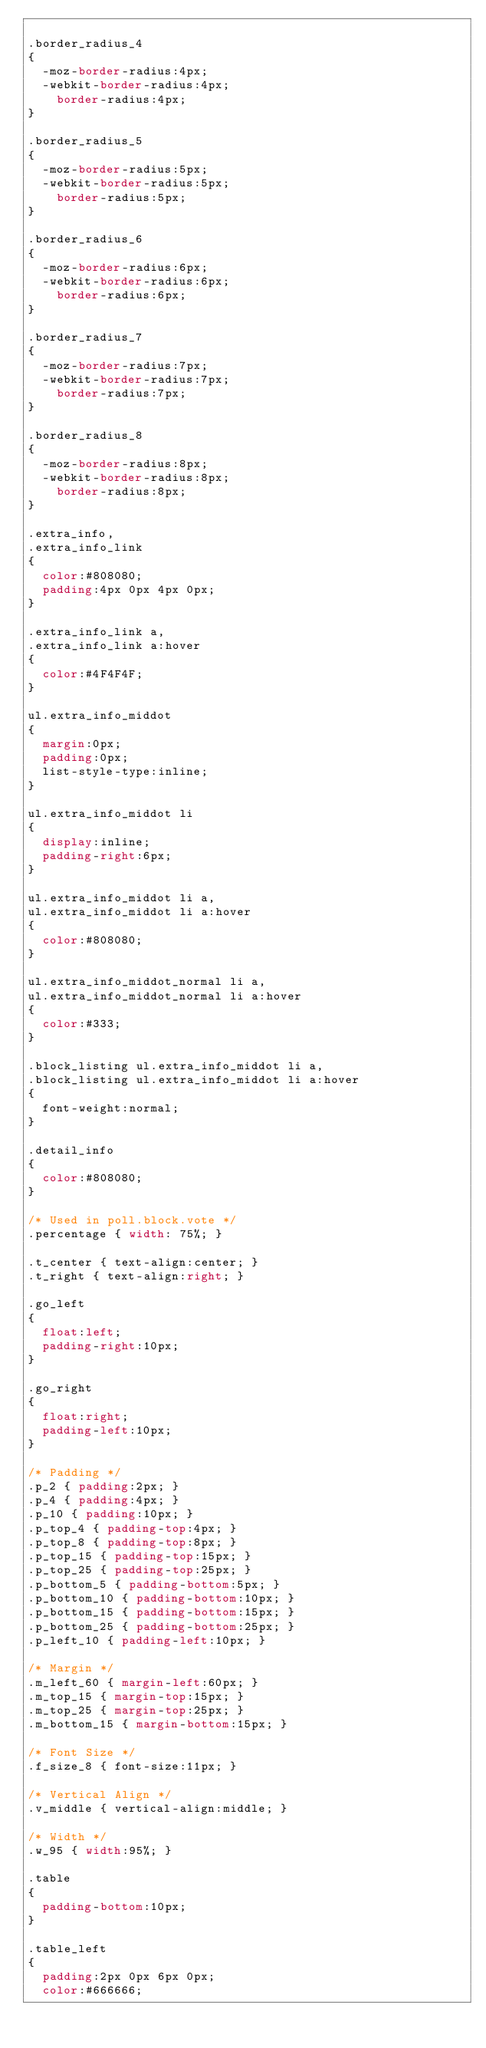<code> <loc_0><loc_0><loc_500><loc_500><_CSS_>
.border_radius_4
{
	-moz-border-radius:4px;
	-webkit-border-radius:4px;
  	border-radius:4px;  	
}

.border_radius_5
{
	-moz-border-radius:5px;
	-webkit-border-radius:5px;
  	border-radius:5px;  	
}

.border_radius_6
{
	-moz-border-radius:6px;
	-webkit-border-radius:6px;
  	border-radius:6px;  	
}

.border_radius_7
{
	-moz-border-radius:7px;
	-webkit-border-radius:7px;
  	border-radius:7px;  	
}

.border_radius_8
{
	-moz-border-radius:8px;
	-webkit-border-radius:8px;
  	border-radius:8px;  	
}

.extra_info,
.extra_info_link
{
	color:#808080;
	padding:4px 0px 4px 0px;	
}

.extra_info_link a,
.extra_info_link a:hover
{
	color:#4F4F4F;
}

ul.extra_info_middot
{
	margin:0px;
	padding:0px;
	list-style-type:inline;
}

ul.extra_info_middot li
{
	display:inline;
	padding-right:6px;
}

ul.extra_info_middot li a,
ul.extra_info_middot li a:hover
{
	color:#808080;	
}

ul.extra_info_middot_normal li a,
ul.extra_info_middot_normal li a:hover
{
	color:#333;	
}

.block_listing ul.extra_info_middot li a,
.block_listing ul.extra_info_middot li a:hover
{
	font-weight:normal;
}

.detail_info
{
	color:#808080;
}

/* Used in poll.block.vote */
.percentage { width: 75%; }

.t_center { text-align:center; }
.t_right { text-align:right; }

.go_left
{
	float:left;
	padding-right:10px;
}

.go_right
{
	float:right;
	padding-left:10px;
}

/* Padding */
.p_2 { padding:2px; }
.p_4 { padding:4px; }
.p_10 { padding:10px; }
.p_top_4 { padding-top:4px; }
.p_top_8 { padding-top:8px; }
.p_top_15 { padding-top:15px; }
.p_top_25 { padding-top:25px; }
.p_bottom_5 { padding-bottom:5px; }
.p_bottom_10 { padding-bottom:10px; }
.p_bottom_15 { padding-bottom:15px; }
.p_bottom_25 { padding-bottom:25px; }
.p_left_10 { padding-left:10px; }

/* Margin */
.m_left_60 { margin-left:60px; }
.m_top_15 { margin-top:15px; }
.m_top_25 { margin-top:25px; }
.m_bottom_15 { margin-bottom:15px; }

/* Font Size */
.f_size_8 { font-size:11px; }

/* Vertical Align */
.v_middle { vertical-align:middle; }

/* Width */
.w_95 { width:95%; }

.table
{
	padding-bottom:10px;	
}

.table_left
{
	padding:2px 0px 6px 0px; 	
	color:#666666;</code> 